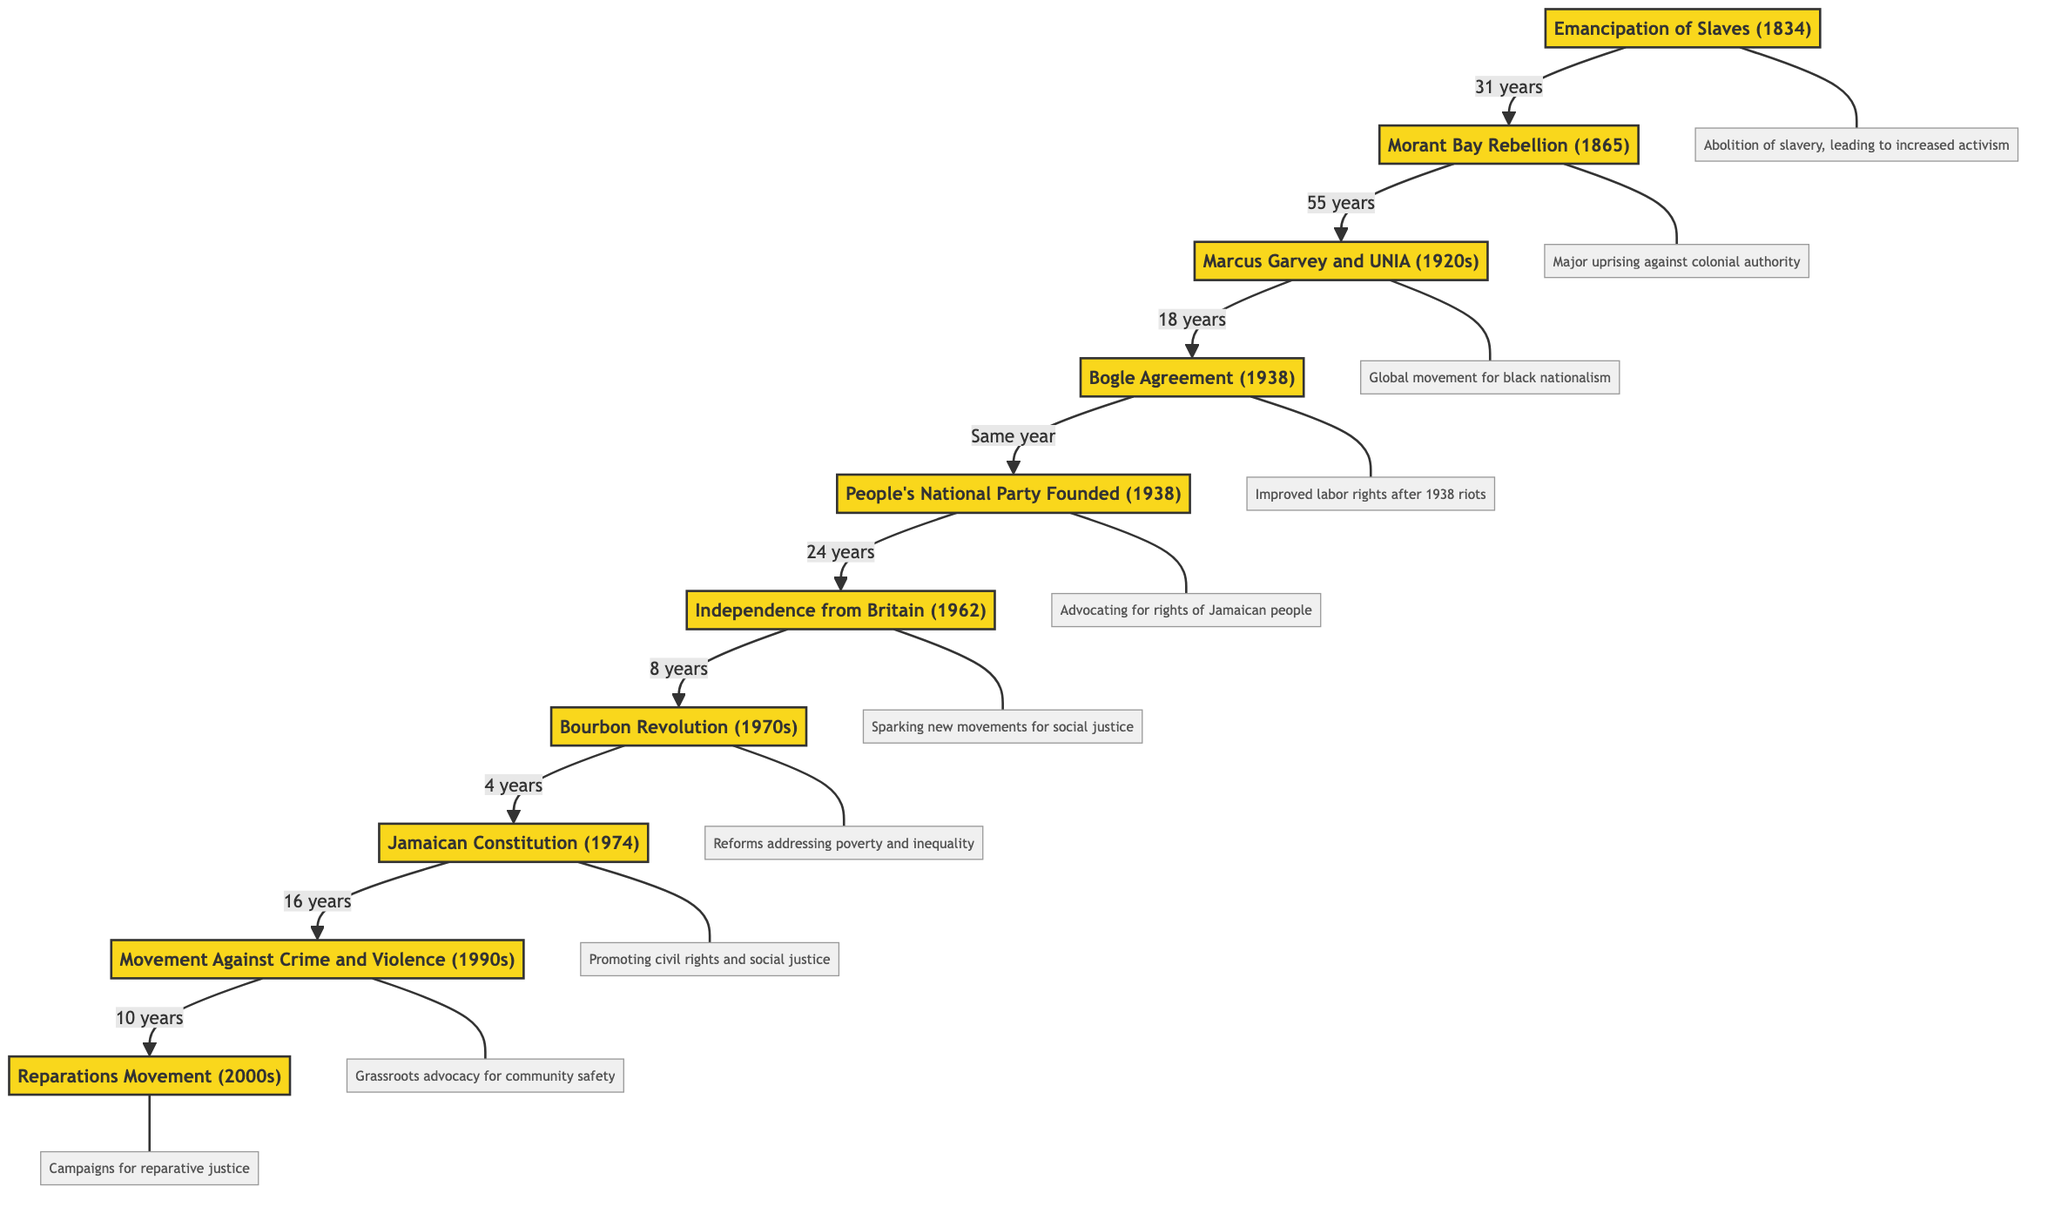What is the first event listed in the diagram? The first event in the diagram is located at the top of the flowchart, which is "Emancipation of Slaves (1834)."
Answer: Emancipation of Slaves (1834) How many nodes are present in the diagram? By counting all the listed events in the nodes section of the diagram, we see there are 10 distinct events.
Answer: 10 What event directly follows the Morant Bay Rebellion (1865)? The arrow from "Morant Bay Rebellion (1865)" points to "Marcus Garvey and the UNIA (1920s)," indicating that it follows consecutively in the timeline.
Answer: Marcus Garvey and the UNIA (1920s) Which event led to the formation of the People's National Party? The edge connecting "Bogle Agreement (1938)" to "People's National Party Founded (1938)" indicates that the Bogle Agreement was a precursor to the formation of the party.
Answer: Bogle Agreement (1938) How many years passed between Independence from Britain and the Bourbon Revolution? The diagram shows that 8 years passed from "Independence from Britain (1962)" to "Bourbon Revolution and Social Change (1970s)."
Answer: 8 years What movement is connected to the Movement Against Crime and Violence? The flow indicates that the "Reparations Movement (2000s)" follows from the "Movement Against Crime and Violence (1990s)," showing a direct connection.
Answer: Reparations Movement (2000s) What significant change occurred as a result of the Jamaican Constitution (1974)? The connection with "Movement Against Crime and Violence (1990s)" indicates that the constitutional reforms promoted civil rights and social justice, leading to grassroots movements.
Answer: Promoting civil rights and social justice Which event is the last in the timeline? The last node leading from the previous events is "Reparations Movement (2000s)," indicating it is the final event depicted in the entire timeline.
Answer: Reparations Movement (2000s) What are the two major events that occurred in 1938? The diagram indicates that both the "Bogle Agreement" and the "People's National Party" were established in the same year of 1938, showing their close historical connection.
Answer: Bogle Agreement and People's National Party Founded 